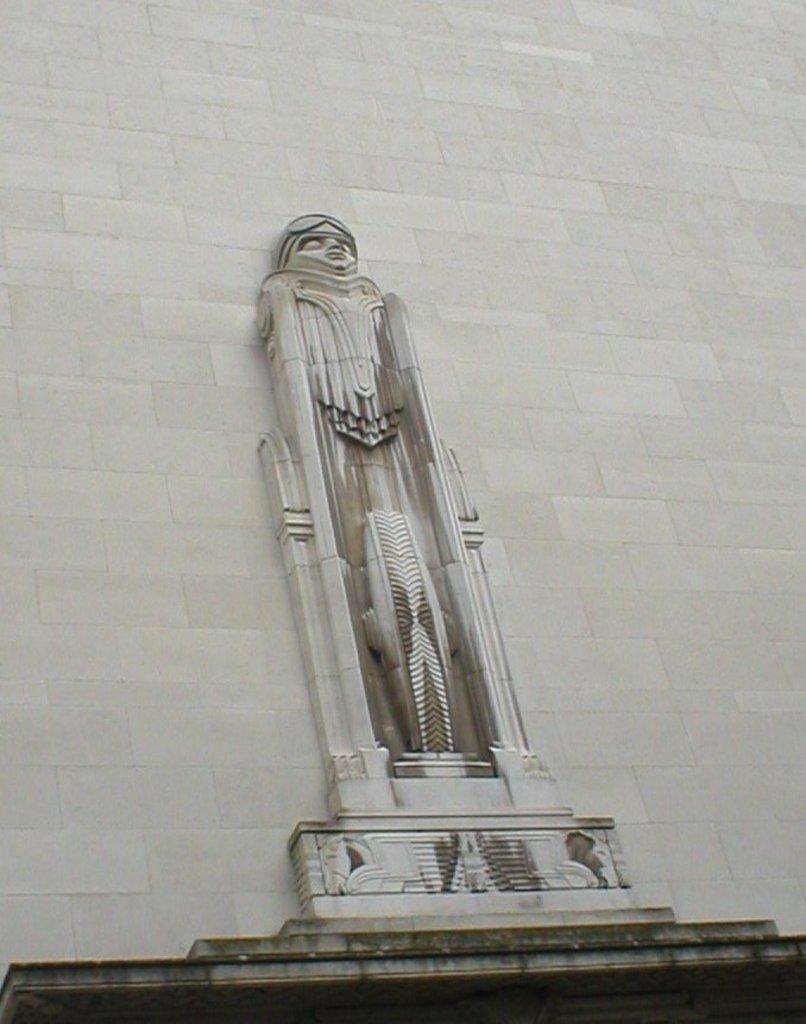Please provide a concise description of this image. In this image we can see a statue and in the background, we can see the wall. 